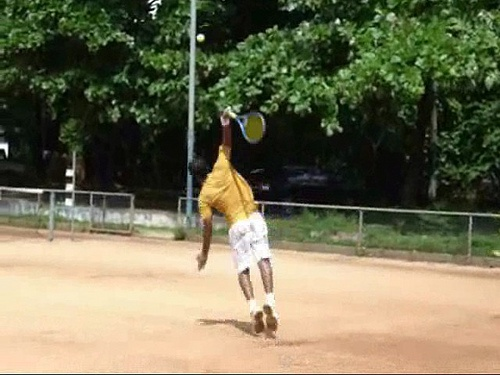Describe the objects in this image and their specific colors. I can see people in darkgreen, white, tan, and black tones, car in darkgreen, black, and gray tones, tennis racket in darkgreen, olive, gray, black, and darkgray tones, and sports ball in darkgreen, beige, gray, khaki, and olive tones in this image. 